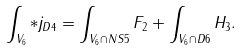Convert formula to latex. <formula><loc_0><loc_0><loc_500><loc_500>\int _ { V _ { 6 } } * j _ { D 4 } = \int _ { V _ { 6 } \cap N S 5 } F _ { 2 } + \int _ { V _ { 6 } \cap D 6 } H _ { 3 } .</formula> 